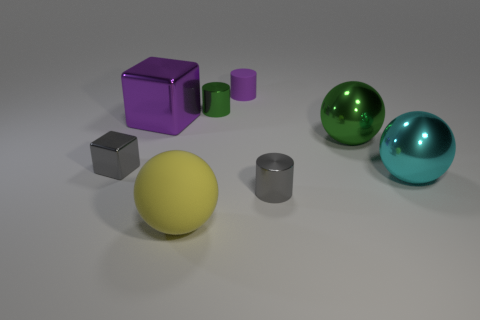Add 2 green shiny objects. How many objects exist? 10 Subtract all blocks. How many objects are left? 6 Subtract all yellow matte objects. Subtract all small purple matte cylinders. How many objects are left? 6 Add 8 green spheres. How many green spheres are left? 9 Add 4 big metallic blocks. How many big metallic blocks exist? 5 Subtract 0 yellow blocks. How many objects are left? 8 